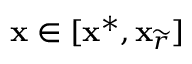<formula> <loc_0><loc_0><loc_500><loc_500>x \in [ x ^ { * } , x _ { \widetilde { r } } ]</formula> 